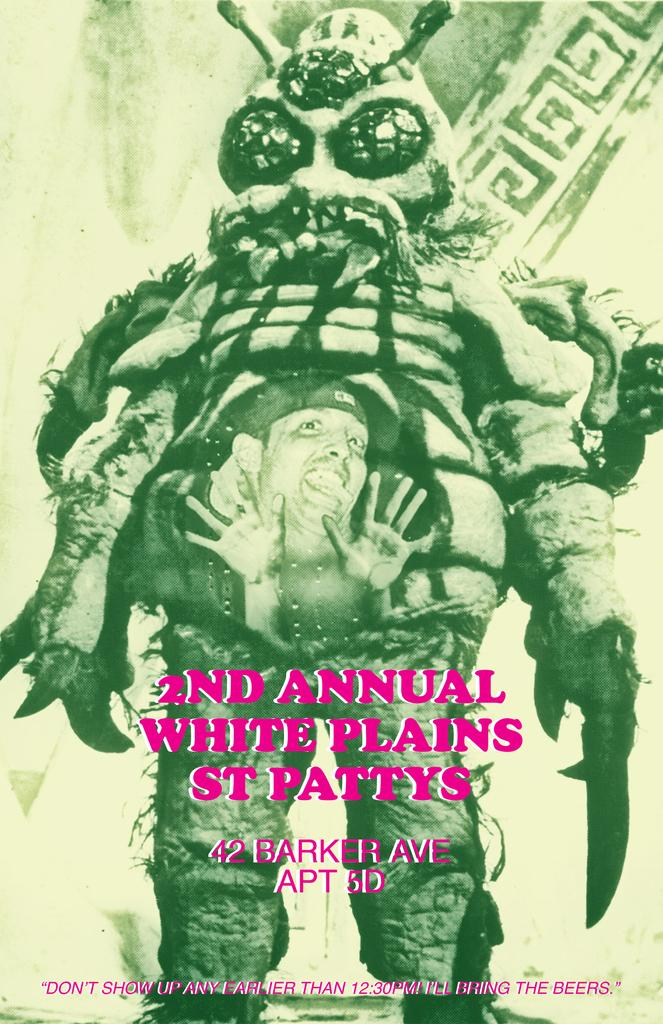What type of content is depicted in the image? There is a cartoon in the image. Can you describe the presence of a human figure in the image? There is a person in the image. What else is included in the image besides the cartoon and person? There is text in the image. Where is the playground located in the image? There is no playground present in the image. What act is the person performing in the image? The image does not depict the person performing any specific act. 